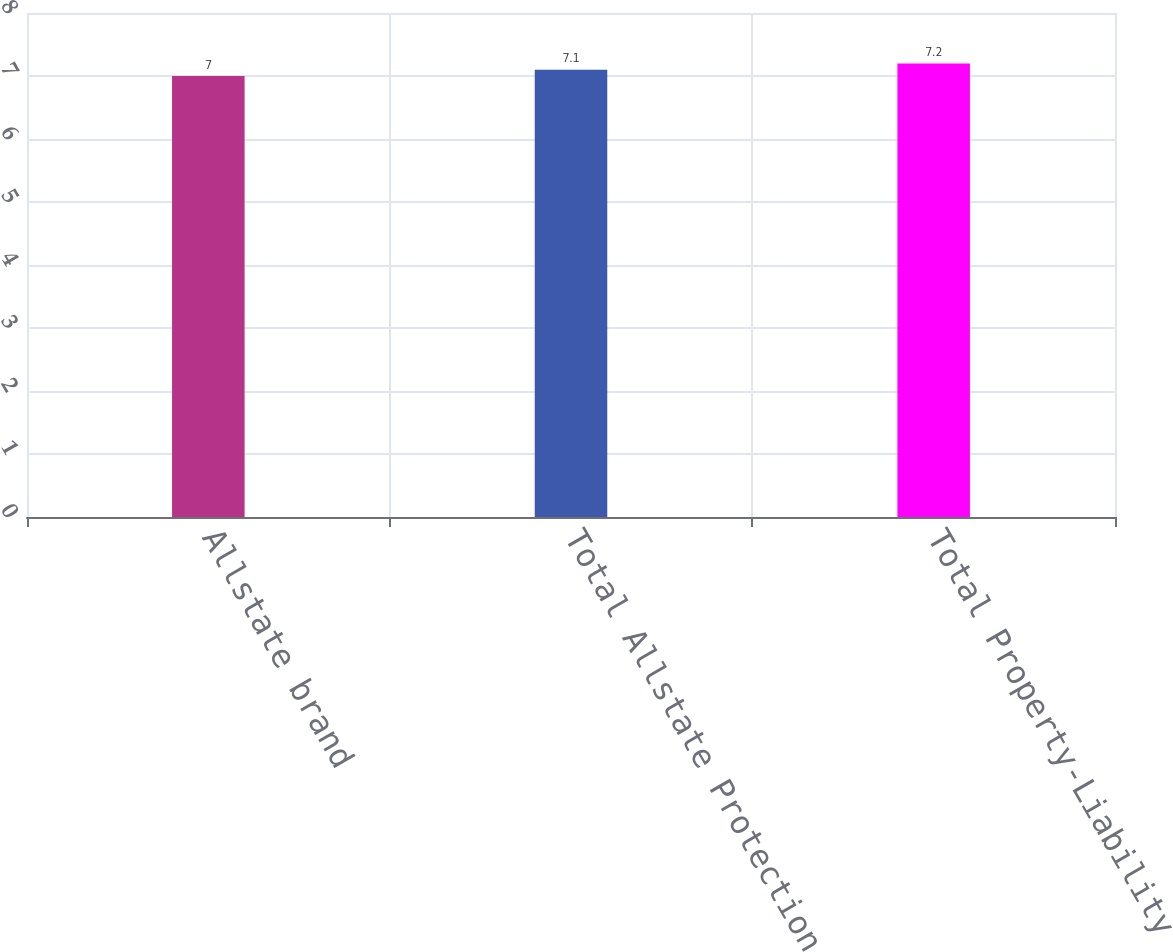Convert chart to OTSL. <chart><loc_0><loc_0><loc_500><loc_500><bar_chart><fcel>Allstate brand<fcel>Total Allstate Protection<fcel>Total Property-Liability<nl><fcel>7<fcel>7.1<fcel>7.2<nl></chart> 